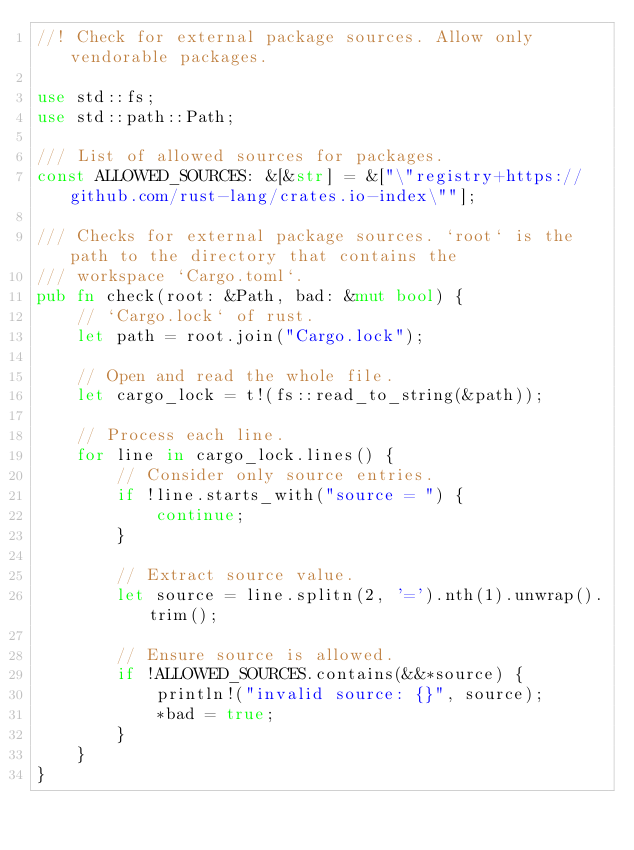Convert code to text. <code><loc_0><loc_0><loc_500><loc_500><_Rust_>//! Check for external package sources. Allow only vendorable packages.

use std::fs;
use std::path::Path;

/// List of allowed sources for packages.
const ALLOWED_SOURCES: &[&str] = &["\"registry+https://github.com/rust-lang/crates.io-index\""];

/// Checks for external package sources. `root` is the path to the directory that contains the
/// workspace `Cargo.toml`.
pub fn check(root: &Path, bad: &mut bool) {
    // `Cargo.lock` of rust.
    let path = root.join("Cargo.lock");

    // Open and read the whole file.
    let cargo_lock = t!(fs::read_to_string(&path));

    // Process each line.
    for line in cargo_lock.lines() {
        // Consider only source entries.
        if !line.starts_with("source = ") {
            continue;
        }

        // Extract source value.
        let source = line.splitn(2, '=').nth(1).unwrap().trim();

        // Ensure source is allowed.
        if !ALLOWED_SOURCES.contains(&&*source) {
            println!("invalid source: {}", source);
            *bad = true;
        }
    }
}
</code> 